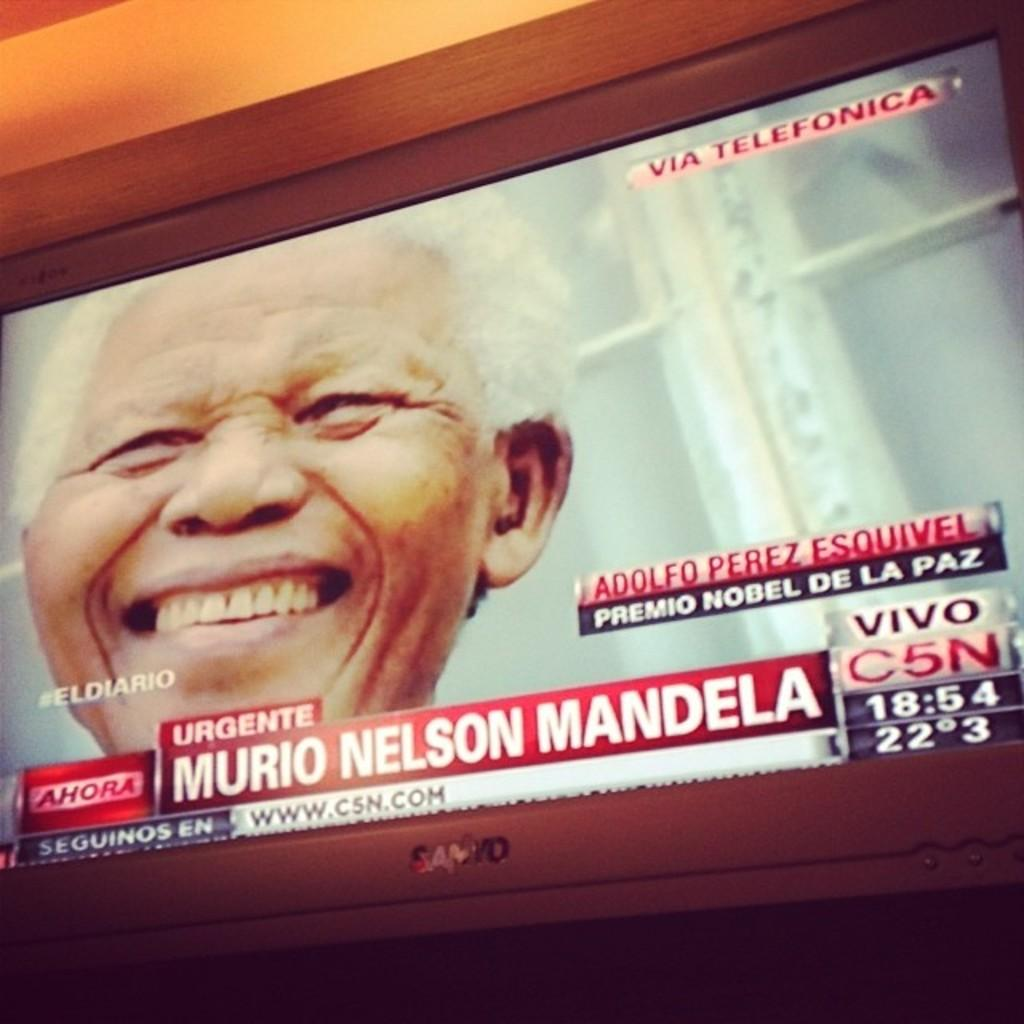What electronic device is present in the image? There is a television in the image. What is happening on the television? A person is visible on the television, smiling. Is there any text displayed on the television? Yes, there is edited text displayed on the television. Is there a guitar being played by the pig on the television? There is no guitar or pig present on the television; it displays a person and edited text. 